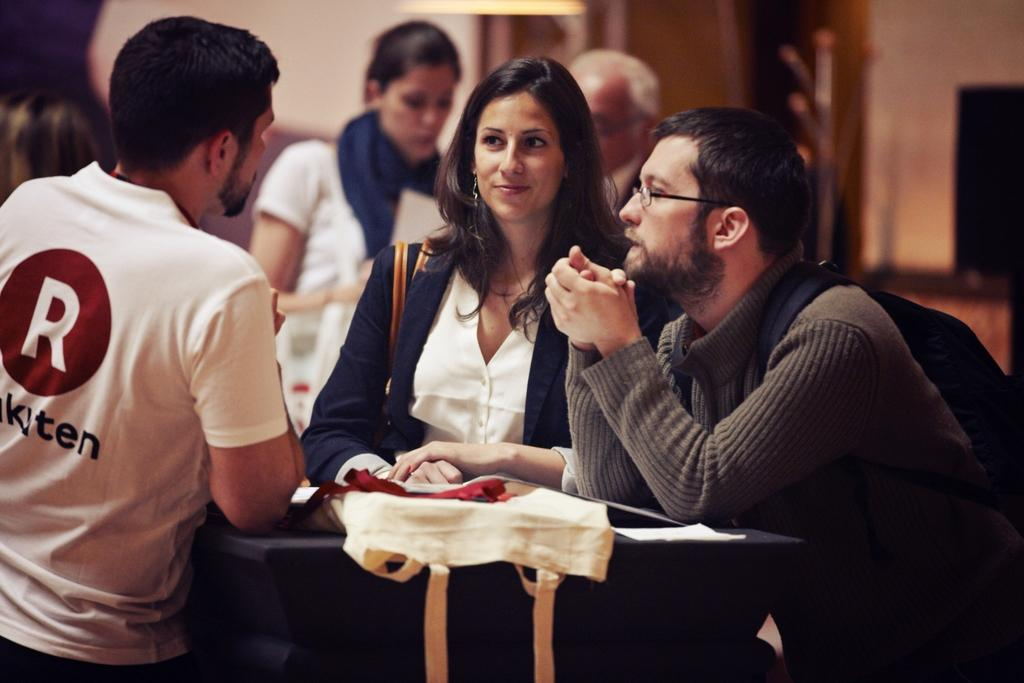What is the main subject of the image? The main subject of the image is a group of people standing and a man sitting. What is in front of the people? There is a table in front of the people. What is on the table? There is a bag on the table. Can you describe the background of the image? The background of the image is blurry. How many times did the people kiss in the image? There is no indication of kissing in the image; it shows a group of people standing and a man sitting. 